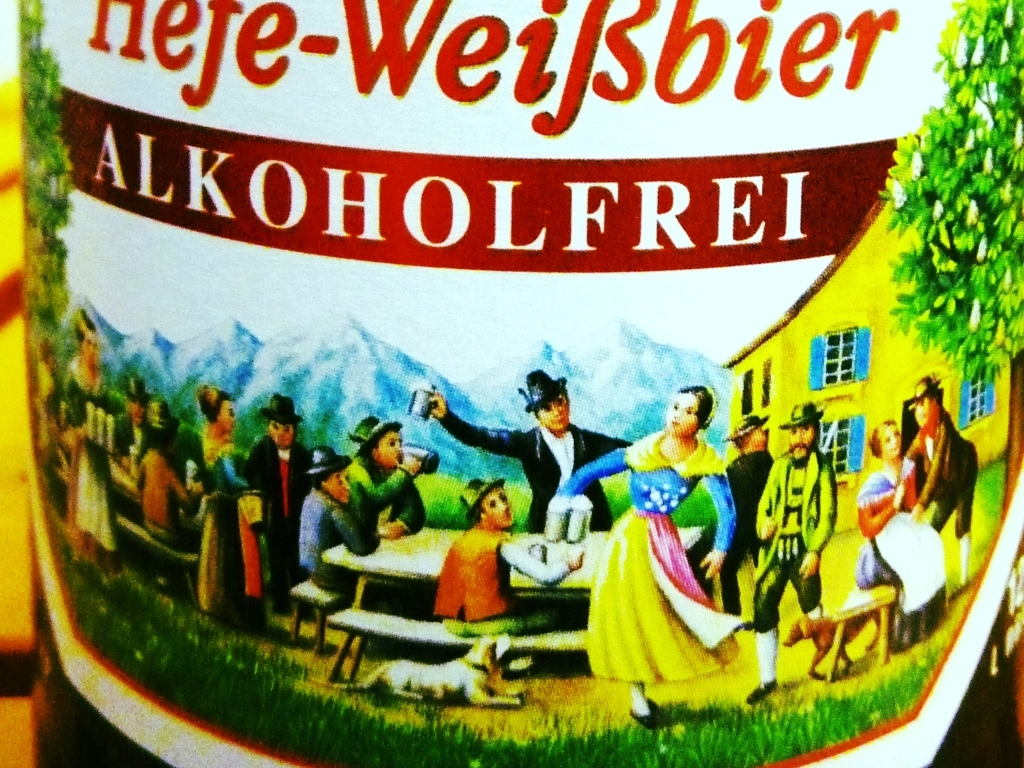Is the text in the image clear? The text displayed within the image is perfectly legible and sharp. It reads 'hefe-Weißbier ALKOHOLFREI,' which translates from German to 'yeast wheat beer ALCOHOL-FREE.' The font is clear, with sufficient contrast against the background, making it easy to read. 